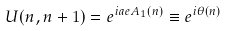<formula> <loc_0><loc_0><loc_500><loc_500>U ( n , n + 1 ) = e ^ { i a e A _ { 1 } ( n ) } \equiv e ^ { i \theta ( n ) }</formula> 